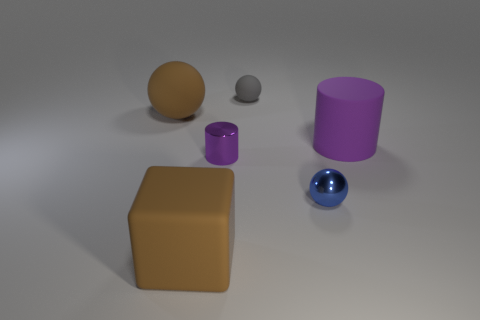What is the material of the gray object on the left side of the cylinder behind the cylinder left of the metallic sphere?
Your answer should be compact. Rubber. Do the big block and the purple object left of the small metal ball have the same material?
Offer a very short reply. No. There is a large brown thing that is the same shape as the gray object; what is it made of?
Offer a terse response. Rubber. Is the number of brown rubber things that are on the left side of the gray thing greater than the number of brown rubber spheres that are in front of the metal sphere?
Provide a short and direct response. Yes. There is a blue thing that is made of the same material as the tiny purple cylinder; what is its shape?
Ensure brevity in your answer.  Sphere. How many other things are there of the same shape as the gray matte object?
Make the answer very short. 2. There is a brown thing behind the big cylinder; what is its shape?
Provide a short and direct response. Sphere. What is the color of the big cube?
Offer a terse response. Brown. What number of other things are there of the same size as the gray rubber sphere?
Your answer should be compact. 2. There is a large brown object that is behind the matte object that is on the right side of the tiny blue metal thing; what is it made of?
Your answer should be compact. Rubber. 